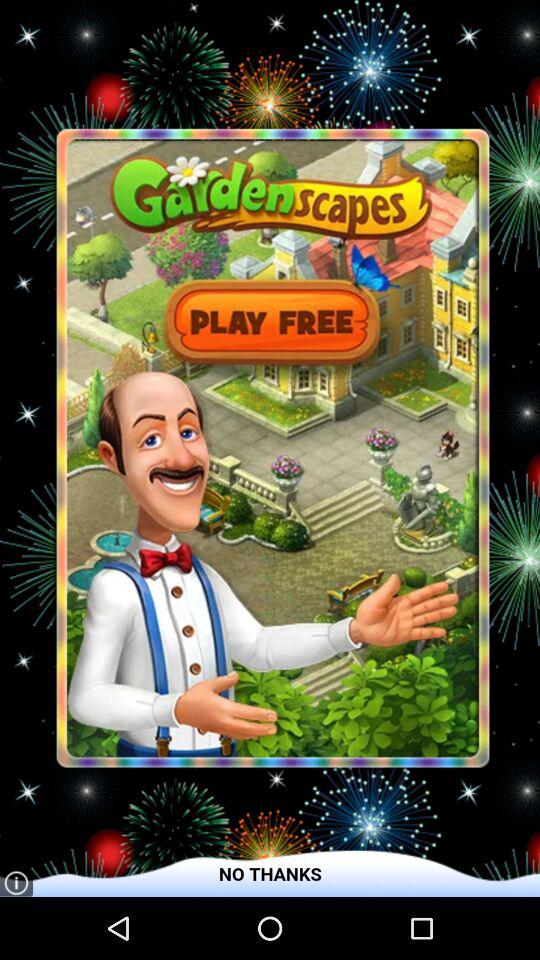Which version number of "Gardenscapes" is this?
When the provided information is insufficient, respond with <no answer>. <no answer> 